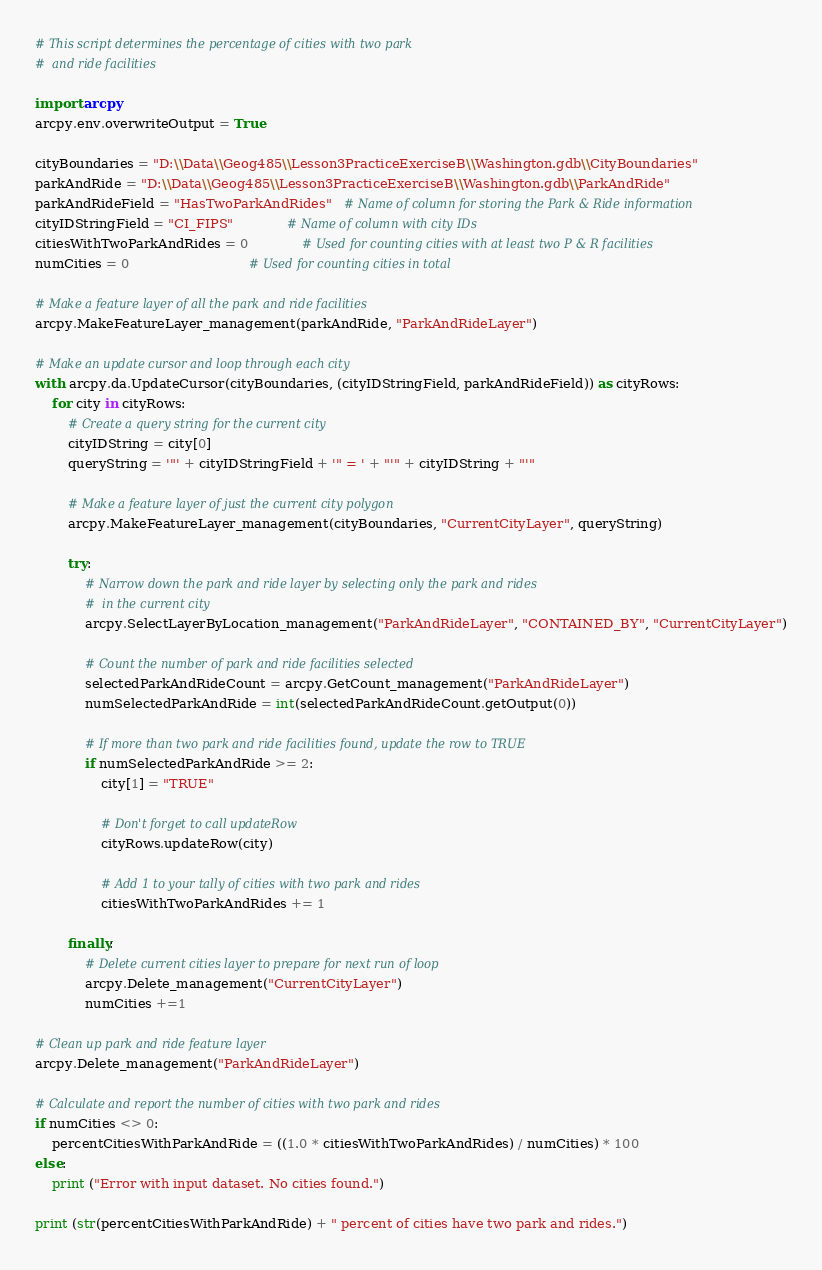<code> <loc_0><loc_0><loc_500><loc_500><_Python_># This script determines the percentage of cities with two park
#  and ride facilities
 
import arcpy
arcpy.env.overwriteOutput = True
 
cityBoundaries = "D:\\Data\\Geog485\\Lesson3PracticeExerciseB\\Washington.gdb\\CityBoundaries"
parkAndRide = "D:\\Data\\Geog485\\Lesson3PracticeExerciseB\\Washington.gdb\\ParkAndRide"
parkAndRideField = "HasTwoParkAndRides"   # Name of column for storing the Park & Ride information
cityIDStringField = "CI_FIPS"             # Name of column with city IDs
citiesWithTwoParkAndRides = 0             # Used for counting cities with at least two P & R facilities
numCities = 0                             # Used for counting cities in total
 
# Make a feature layer of all the park and ride facilities
arcpy.MakeFeatureLayer_management(parkAndRide, "ParkAndRideLayer")
 
# Make an update cursor and loop through each city
with arcpy.da.UpdateCursor(cityBoundaries, (cityIDStringField, parkAndRideField)) as cityRows:
    for city in cityRows:
        # Create a query string for the current city    
        cityIDString = city[0]
        queryString = '"' + cityIDStringField + '" = ' + "'" + cityIDString + "'"
 
        # Make a feature layer of just the current city polygon    
        arcpy.MakeFeatureLayer_management(cityBoundaries, "CurrentCityLayer", queryString)
 
        try:
            # Narrow down the park and ride layer by selecting only the park and rides
            #  in the current city
            arcpy.SelectLayerByLocation_management("ParkAndRideLayer", "CONTAINED_BY", "CurrentCityLayer")
 
            # Count the number of park and ride facilities selected
            selectedParkAndRideCount = arcpy.GetCount_management("ParkAndRideLayer")
            numSelectedParkAndRide = int(selectedParkAndRideCount.getOutput(0))
 
            # If more than two park and ride facilities found, update the row to TRUE
            if numSelectedParkAndRide >= 2:
                city[1] = "TRUE"
 
                # Don't forget to call updateRow
                cityRows.updateRow(city)
 
                # Add 1 to your tally of cities with two park and rides                
                citiesWithTwoParkAndRides += 1
 
        finally:
            # Delete current cities layer to prepare for next run of loop
            arcpy.Delete_management("CurrentCityLayer")
            numCities +=1
 
# Clean up park and ride feature layer
arcpy.Delete_management("ParkAndRideLayer")
 
# Calculate and report the number of cities with two park and rides
if numCities <> 0:
    percentCitiesWithParkAndRide = ((1.0 * citiesWithTwoParkAndRides) / numCities) * 100
else:
    print ("Error with input dataset. No cities found.")
 
print (str(percentCitiesWithParkAndRide) + " percent of cities have two park and rides.")</code> 